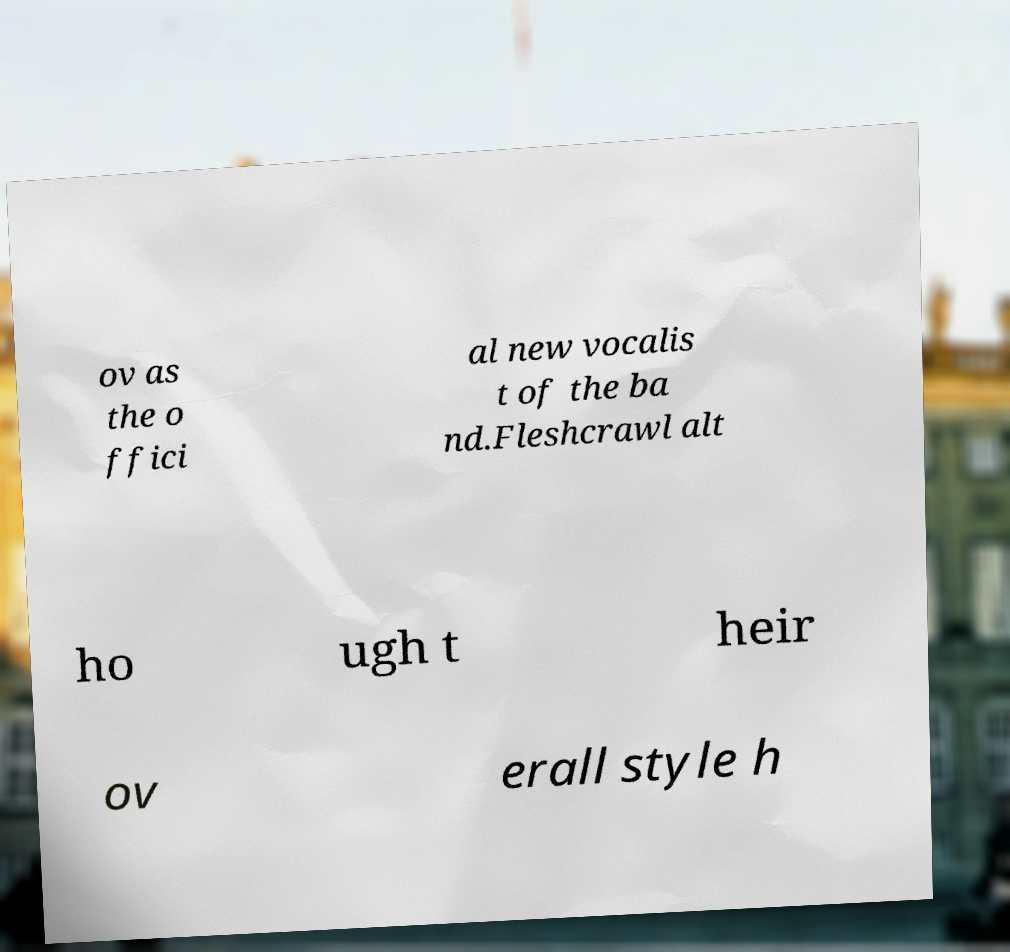Could you assist in decoding the text presented in this image and type it out clearly? ov as the o ffici al new vocalis t of the ba nd.Fleshcrawl alt ho ugh t heir ov erall style h 